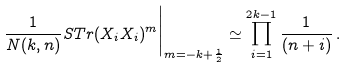Convert formula to latex. <formula><loc_0><loc_0><loc_500><loc_500>\frac { 1 } { N ( k , n ) } S T r ( X _ { i } X _ { i } ) ^ { m } \Big | _ { m = - k + \frac { 1 } { 2 } } \simeq \prod _ { i = 1 } ^ { 2 k - 1 } \frac { 1 } { ( n + i ) } \, .</formula> 